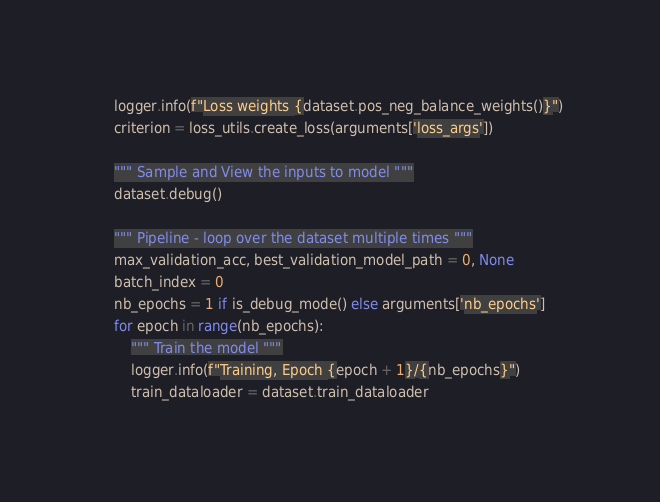<code> <loc_0><loc_0><loc_500><loc_500><_Python_>    logger.info(f"Loss weights {dataset.pos_neg_balance_weights()}")
    criterion = loss_utils.create_loss(arguments['loss_args'])

    """ Sample and View the inputs to model """
    dataset.debug()

    """ Pipeline - loop over the dataset multiple times """
    max_validation_acc, best_validation_model_path = 0, None
    batch_index = 0
    nb_epochs = 1 if is_debug_mode() else arguments['nb_epochs']
    for epoch in range(nb_epochs):
        """ Train the model """
        logger.info(f"Training, Epoch {epoch + 1}/{nb_epochs}")
        train_dataloader = dataset.train_dataloader</code> 